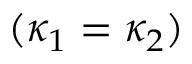Convert formula to latex. <formula><loc_0><loc_0><loc_500><loc_500>( \kappa _ { 1 } = \kappa _ { 2 } )</formula> 